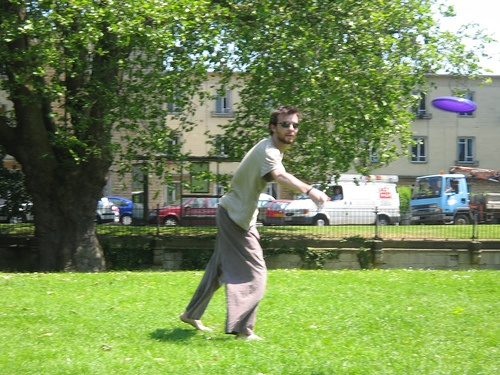Describe the objects in this image and their specific colors. I can see people in black, gray, lightgray, and darkgray tones, truck in black, white, gray, and darkgray tones, truck in black, gray, and lightblue tones, car in black, gray, darkgray, and maroon tones, and car in black, gray, darkgray, and white tones in this image. 